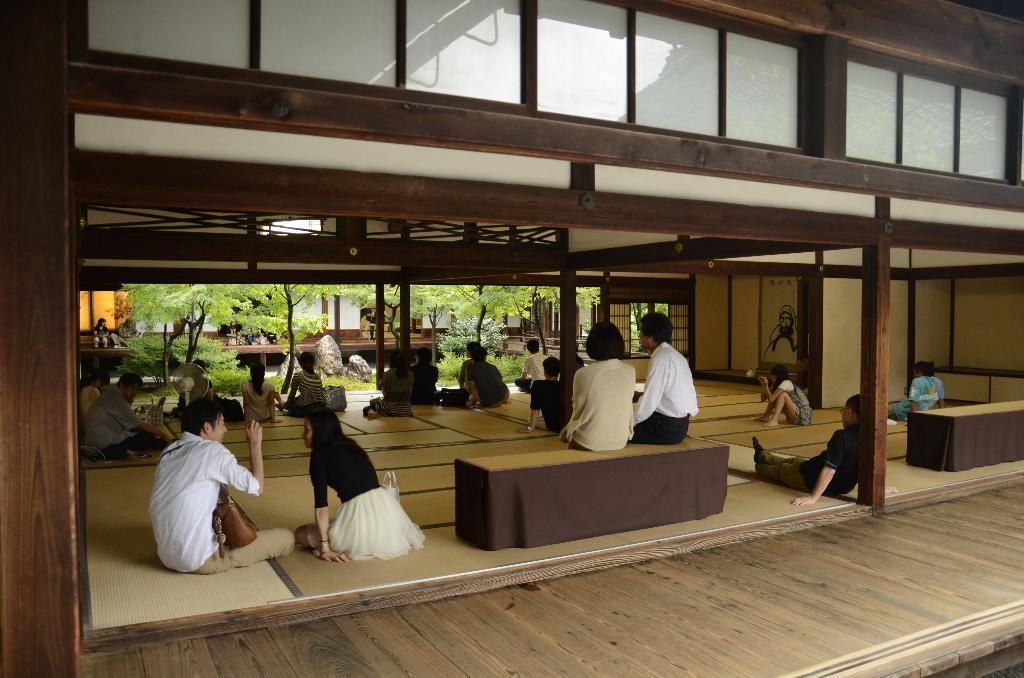What are the people in the image doing? The people in the image are sitting on the floor. Are there any other seating options visible in the image? Yes, there are two persons sitting on a bench. What structures can be seen in the image? There are poles, benches, and a wall visible in the image. What type of vegetation is present in the image? There are plants and trees in the image. Can you see any birds flying over the lake in the image? There is no lake or birds present in the image. What is the occasion for the birth celebration in the image? There is no mention of a birth or celebration in the image. 